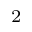<formula> <loc_0><loc_0><loc_500><loc_500>_ { 2 }</formula> 